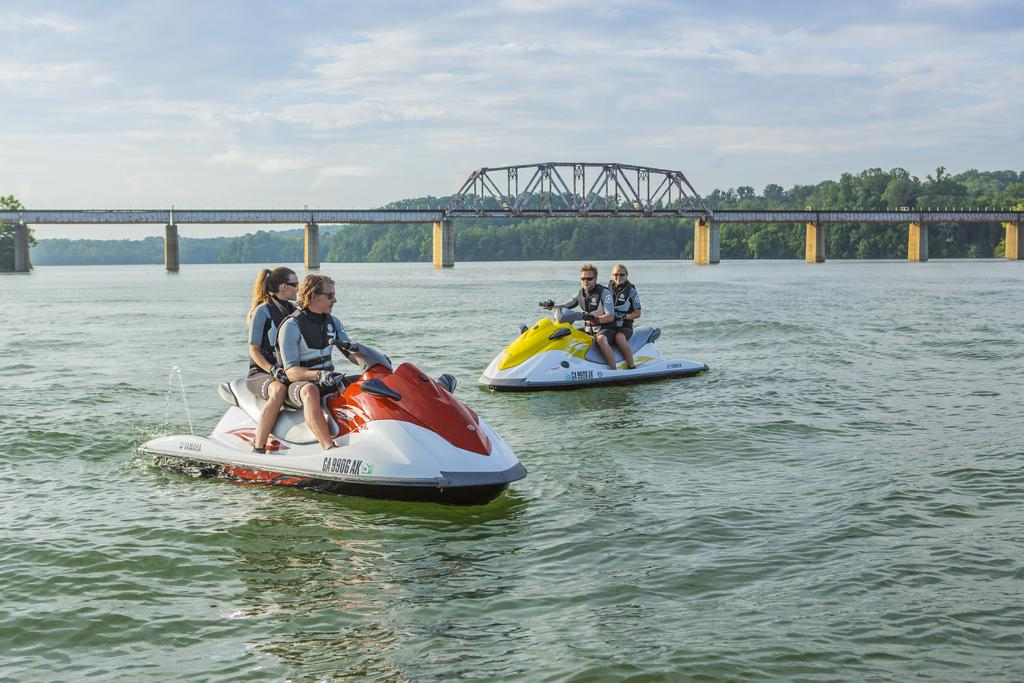What are the people in the image doing? The people in the image are riding speed boats. What structure can be seen in the image? There is a bridge in the image. What type of natural environment is visible in the image? There are trees visible in the image. What type of agreement was reached by the trees in the image? There is no indication of any agreement in the image, as trees do not have the ability to make agreements. 